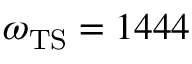Convert formula to latex. <formula><loc_0><loc_0><loc_500><loc_500>\omega _ { T S } = 1 4 4 4</formula> 